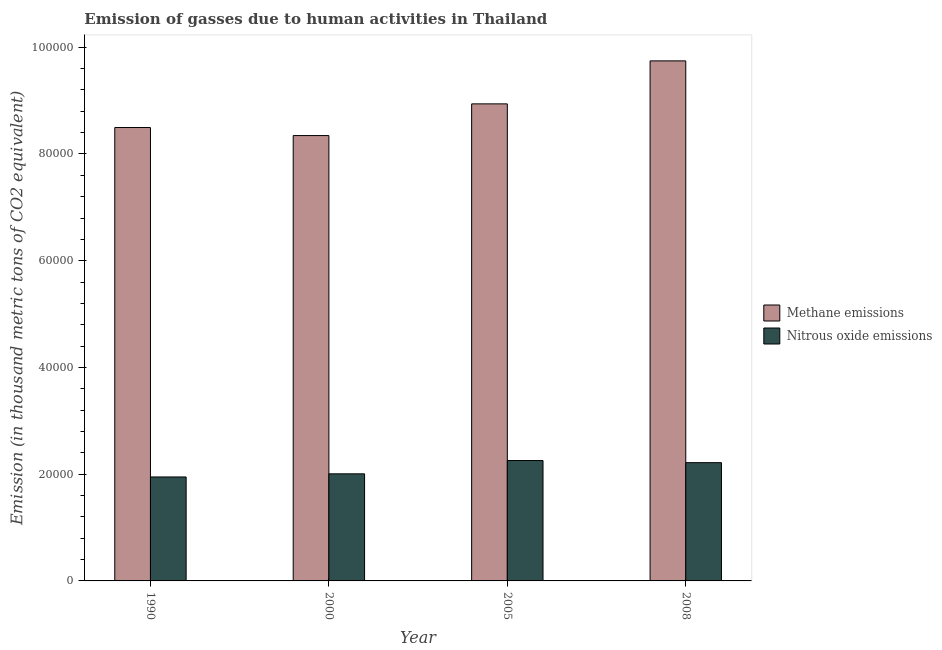How many different coloured bars are there?
Ensure brevity in your answer.  2. What is the amount of methane emissions in 2000?
Keep it short and to the point. 8.34e+04. Across all years, what is the maximum amount of methane emissions?
Offer a very short reply. 9.74e+04. Across all years, what is the minimum amount of nitrous oxide emissions?
Ensure brevity in your answer.  1.95e+04. In which year was the amount of nitrous oxide emissions maximum?
Ensure brevity in your answer.  2005. What is the total amount of nitrous oxide emissions in the graph?
Ensure brevity in your answer.  8.43e+04. What is the difference between the amount of methane emissions in 2000 and that in 2008?
Offer a terse response. -1.40e+04. What is the difference between the amount of nitrous oxide emissions in 1990 and the amount of methane emissions in 2000?
Offer a very short reply. -586.2. What is the average amount of nitrous oxide emissions per year?
Your answer should be compact. 2.11e+04. What is the ratio of the amount of methane emissions in 2000 to that in 2005?
Your answer should be very brief. 0.93. Is the amount of methane emissions in 2000 less than that in 2005?
Offer a terse response. Yes. What is the difference between the highest and the second highest amount of methane emissions?
Your answer should be compact. 8056. What is the difference between the highest and the lowest amount of methane emissions?
Your answer should be very brief. 1.40e+04. In how many years, is the amount of nitrous oxide emissions greater than the average amount of nitrous oxide emissions taken over all years?
Provide a succinct answer. 2. What does the 2nd bar from the left in 1990 represents?
Provide a short and direct response. Nitrous oxide emissions. What does the 1st bar from the right in 2005 represents?
Provide a short and direct response. Nitrous oxide emissions. How many bars are there?
Offer a very short reply. 8. Are all the bars in the graph horizontal?
Provide a succinct answer. No. What is the difference between two consecutive major ticks on the Y-axis?
Your answer should be very brief. 2.00e+04. Does the graph contain grids?
Give a very brief answer. No. What is the title of the graph?
Make the answer very short. Emission of gasses due to human activities in Thailand. What is the label or title of the Y-axis?
Ensure brevity in your answer.  Emission (in thousand metric tons of CO2 equivalent). What is the Emission (in thousand metric tons of CO2 equivalent) of Methane emissions in 1990?
Your response must be concise. 8.50e+04. What is the Emission (in thousand metric tons of CO2 equivalent) of Nitrous oxide emissions in 1990?
Provide a succinct answer. 1.95e+04. What is the Emission (in thousand metric tons of CO2 equivalent) of Methane emissions in 2000?
Make the answer very short. 8.34e+04. What is the Emission (in thousand metric tons of CO2 equivalent) in Nitrous oxide emissions in 2000?
Keep it short and to the point. 2.01e+04. What is the Emission (in thousand metric tons of CO2 equivalent) in Methane emissions in 2005?
Ensure brevity in your answer.  8.94e+04. What is the Emission (in thousand metric tons of CO2 equivalent) of Nitrous oxide emissions in 2005?
Provide a succinct answer. 2.26e+04. What is the Emission (in thousand metric tons of CO2 equivalent) of Methane emissions in 2008?
Provide a succinct answer. 9.74e+04. What is the Emission (in thousand metric tons of CO2 equivalent) of Nitrous oxide emissions in 2008?
Your answer should be very brief. 2.22e+04. Across all years, what is the maximum Emission (in thousand metric tons of CO2 equivalent) in Methane emissions?
Keep it short and to the point. 9.74e+04. Across all years, what is the maximum Emission (in thousand metric tons of CO2 equivalent) in Nitrous oxide emissions?
Ensure brevity in your answer.  2.26e+04. Across all years, what is the minimum Emission (in thousand metric tons of CO2 equivalent) of Methane emissions?
Your response must be concise. 8.34e+04. Across all years, what is the minimum Emission (in thousand metric tons of CO2 equivalent) in Nitrous oxide emissions?
Your answer should be very brief. 1.95e+04. What is the total Emission (in thousand metric tons of CO2 equivalent) of Methane emissions in the graph?
Offer a very short reply. 3.55e+05. What is the total Emission (in thousand metric tons of CO2 equivalent) in Nitrous oxide emissions in the graph?
Provide a succinct answer. 8.43e+04. What is the difference between the Emission (in thousand metric tons of CO2 equivalent) of Methane emissions in 1990 and that in 2000?
Provide a short and direct response. 1507.2. What is the difference between the Emission (in thousand metric tons of CO2 equivalent) of Nitrous oxide emissions in 1990 and that in 2000?
Your answer should be compact. -586.2. What is the difference between the Emission (in thousand metric tons of CO2 equivalent) of Methane emissions in 1990 and that in 2005?
Keep it short and to the point. -4432.2. What is the difference between the Emission (in thousand metric tons of CO2 equivalent) of Nitrous oxide emissions in 1990 and that in 2005?
Provide a short and direct response. -3080.2. What is the difference between the Emission (in thousand metric tons of CO2 equivalent) of Methane emissions in 1990 and that in 2008?
Your response must be concise. -1.25e+04. What is the difference between the Emission (in thousand metric tons of CO2 equivalent) in Nitrous oxide emissions in 1990 and that in 2008?
Your answer should be compact. -2680.3. What is the difference between the Emission (in thousand metric tons of CO2 equivalent) in Methane emissions in 2000 and that in 2005?
Give a very brief answer. -5939.4. What is the difference between the Emission (in thousand metric tons of CO2 equivalent) of Nitrous oxide emissions in 2000 and that in 2005?
Your answer should be very brief. -2494. What is the difference between the Emission (in thousand metric tons of CO2 equivalent) of Methane emissions in 2000 and that in 2008?
Provide a short and direct response. -1.40e+04. What is the difference between the Emission (in thousand metric tons of CO2 equivalent) of Nitrous oxide emissions in 2000 and that in 2008?
Offer a terse response. -2094.1. What is the difference between the Emission (in thousand metric tons of CO2 equivalent) in Methane emissions in 2005 and that in 2008?
Ensure brevity in your answer.  -8056. What is the difference between the Emission (in thousand metric tons of CO2 equivalent) of Nitrous oxide emissions in 2005 and that in 2008?
Provide a short and direct response. 399.9. What is the difference between the Emission (in thousand metric tons of CO2 equivalent) of Methane emissions in 1990 and the Emission (in thousand metric tons of CO2 equivalent) of Nitrous oxide emissions in 2000?
Keep it short and to the point. 6.49e+04. What is the difference between the Emission (in thousand metric tons of CO2 equivalent) in Methane emissions in 1990 and the Emission (in thousand metric tons of CO2 equivalent) in Nitrous oxide emissions in 2005?
Make the answer very short. 6.24e+04. What is the difference between the Emission (in thousand metric tons of CO2 equivalent) in Methane emissions in 1990 and the Emission (in thousand metric tons of CO2 equivalent) in Nitrous oxide emissions in 2008?
Your answer should be very brief. 6.28e+04. What is the difference between the Emission (in thousand metric tons of CO2 equivalent) in Methane emissions in 2000 and the Emission (in thousand metric tons of CO2 equivalent) in Nitrous oxide emissions in 2005?
Offer a terse response. 6.09e+04. What is the difference between the Emission (in thousand metric tons of CO2 equivalent) in Methane emissions in 2000 and the Emission (in thousand metric tons of CO2 equivalent) in Nitrous oxide emissions in 2008?
Offer a very short reply. 6.13e+04. What is the difference between the Emission (in thousand metric tons of CO2 equivalent) of Methane emissions in 2005 and the Emission (in thousand metric tons of CO2 equivalent) of Nitrous oxide emissions in 2008?
Provide a short and direct response. 6.72e+04. What is the average Emission (in thousand metric tons of CO2 equivalent) in Methane emissions per year?
Ensure brevity in your answer.  8.88e+04. What is the average Emission (in thousand metric tons of CO2 equivalent) in Nitrous oxide emissions per year?
Offer a very short reply. 2.11e+04. In the year 1990, what is the difference between the Emission (in thousand metric tons of CO2 equivalent) of Methane emissions and Emission (in thousand metric tons of CO2 equivalent) of Nitrous oxide emissions?
Provide a succinct answer. 6.55e+04. In the year 2000, what is the difference between the Emission (in thousand metric tons of CO2 equivalent) of Methane emissions and Emission (in thousand metric tons of CO2 equivalent) of Nitrous oxide emissions?
Offer a terse response. 6.34e+04. In the year 2005, what is the difference between the Emission (in thousand metric tons of CO2 equivalent) in Methane emissions and Emission (in thousand metric tons of CO2 equivalent) in Nitrous oxide emissions?
Your response must be concise. 6.68e+04. In the year 2008, what is the difference between the Emission (in thousand metric tons of CO2 equivalent) in Methane emissions and Emission (in thousand metric tons of CO2 equivalent) in Nitrous oxide emissions?
Ensure brevity in your answer.  7.53e+04. What is the ratio of the Emission (in thousand metric tons of CO2 equivalent) of Methane emissions in 1990 to that in 2000?
Provide a short and direct response. 1.02. What is the ratio of the Emission (in thousand metric tons of CO2 equivalent) in Nitrous oxide emissions in 1990 to that in 2000?
Provide a succinct answer. 0.97. What is the ratio of the Emission (in thousand metric tons of CO2 equivalent) in Methane emissions in 1990 to that in 2005?
Provide a succinct answer. 0.95. What is the ratio of the Emission (in thousand metric tons of CO2 equivalent) in Nitrous oxide emissions in 1990 to that in 2005?
Provide a succinct answer. 0.86. What is the ratio of the Emission (in thousand metric tons of CO2 equivalent) of Methane emissions in 1990 to that in 2008?
Give a very brief answer. 0.87. What is the ratio of the Emission (in thousand metric tons of CO2 equivalent) in Nitrous oxide emissions in 1990 to that in 2008?
Keep it short and to the point. 0.88. What is the ratio of the Emission (in thousand metric tons of CO2 equivalent) of Methane emissions in 2000 to that in 2005?
Your answer should be very brief. 0.93. What is the ratio of the Emission (in thousand metric tons of CO2 equivalent) of Nitrous oxide emissions in 2000 to that in 2005?
Ensure brevity in your answer.  0.89. What is the ratio of the Emission (in thousand metric tons of CO2 equivalent) in Methane emissions in 2000 to that in 2008?
Provide a short and direct response. 0.86. What is the ratio of the Emission (in thousand metric tons of CO2 equivalent) in Nitrous oxide emissions in 2000 to that in 2008?
Ensure brevity in your answer.  0.91. What is the ratio of the Emission (in thousand metric tons of CO2 equivalent) of Methane emissions in 2005 to that in 2008?
Offer a terse response. 0.92. What is the difference between the highest and the second highest Emission (in thousand metric tons of CO2 equivalent) in Methane emissions?
Your answer should be compact. 8056. What is the difference between the highest and the second highest Emission (in thousand metric tons of CO2 equivalent) in Nitrous oxide emissions?
Offer a terse response. 399.9. What is the difference between the highest and the lowest Emission (in thousand metric tons of CO2 equivalent) in Methane emissions?
Your answer should be compact. 1.40e+04. What is the difference between the highest and the lowest Emission (in thousand metric tons of CO2 equivalent) in Nitrous oxide emissions?
Provide a succinct answer. 3080.2. 